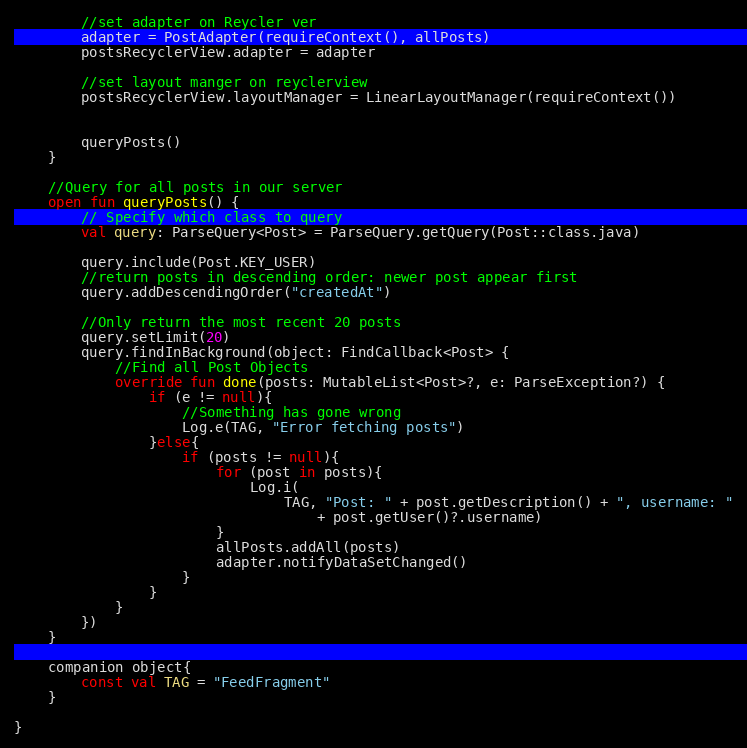<code> <loc_0><loc_0><loc_500><loc_500><_Kotlin_>        //set adapter on Reycler ver
        adapter = PostAdapter(requireContext(), allPosts)
        postsRecyclerView.adapter = adapter

        //set layout manger on reyclerview
        postsRecyclerView.layoutManager = LinearLayoutManager(requireContext())


        queryPosts()
    }

    //Query for all posts in our server
    open fun queryPosts() {
        // Specify which class to query
        val query: ParseQuery<Post> = ParseQuery.getQuery(Post::class.java)

        query.include(Post.KEY_USER)
        //return posts in descending order: newer post appear first
        query.addDescendingOrder("createdAt")

        //Only return the most recent 20 posts
        query.setLimit(20)
        query.findInBackground(object: FindCallback<Post> {
            //Find all Post Objects
            override fun done(posts: MutableList<Post>?, e: ParseException?) {
                if (e != null){
                    //Something has gone wrong
                    Log.e(TAG, "Error fetching posts")
                }else{
                    if (posts != null){
                        for (post in posts){
                            Log.i(
                                TAG, "Post: " + post.getDescription() + ", username: "
                                    + post.getUser()?.username)
                        }
                        allPosts.addAll(posts)
                        adapter.notifyDataSetChanged()
                    }
                }
            }
        })
    }

    companion object{
        const val TAG = "FeedFragment"
    }

}</code> 